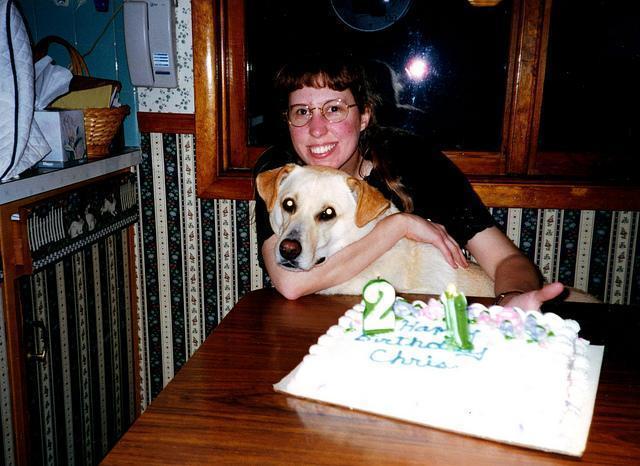Where is the dog sitting?
Make your selection from the four choices given to correctly answer the question.
Options: Bench, crate, window, girls lap. Girls lap. 